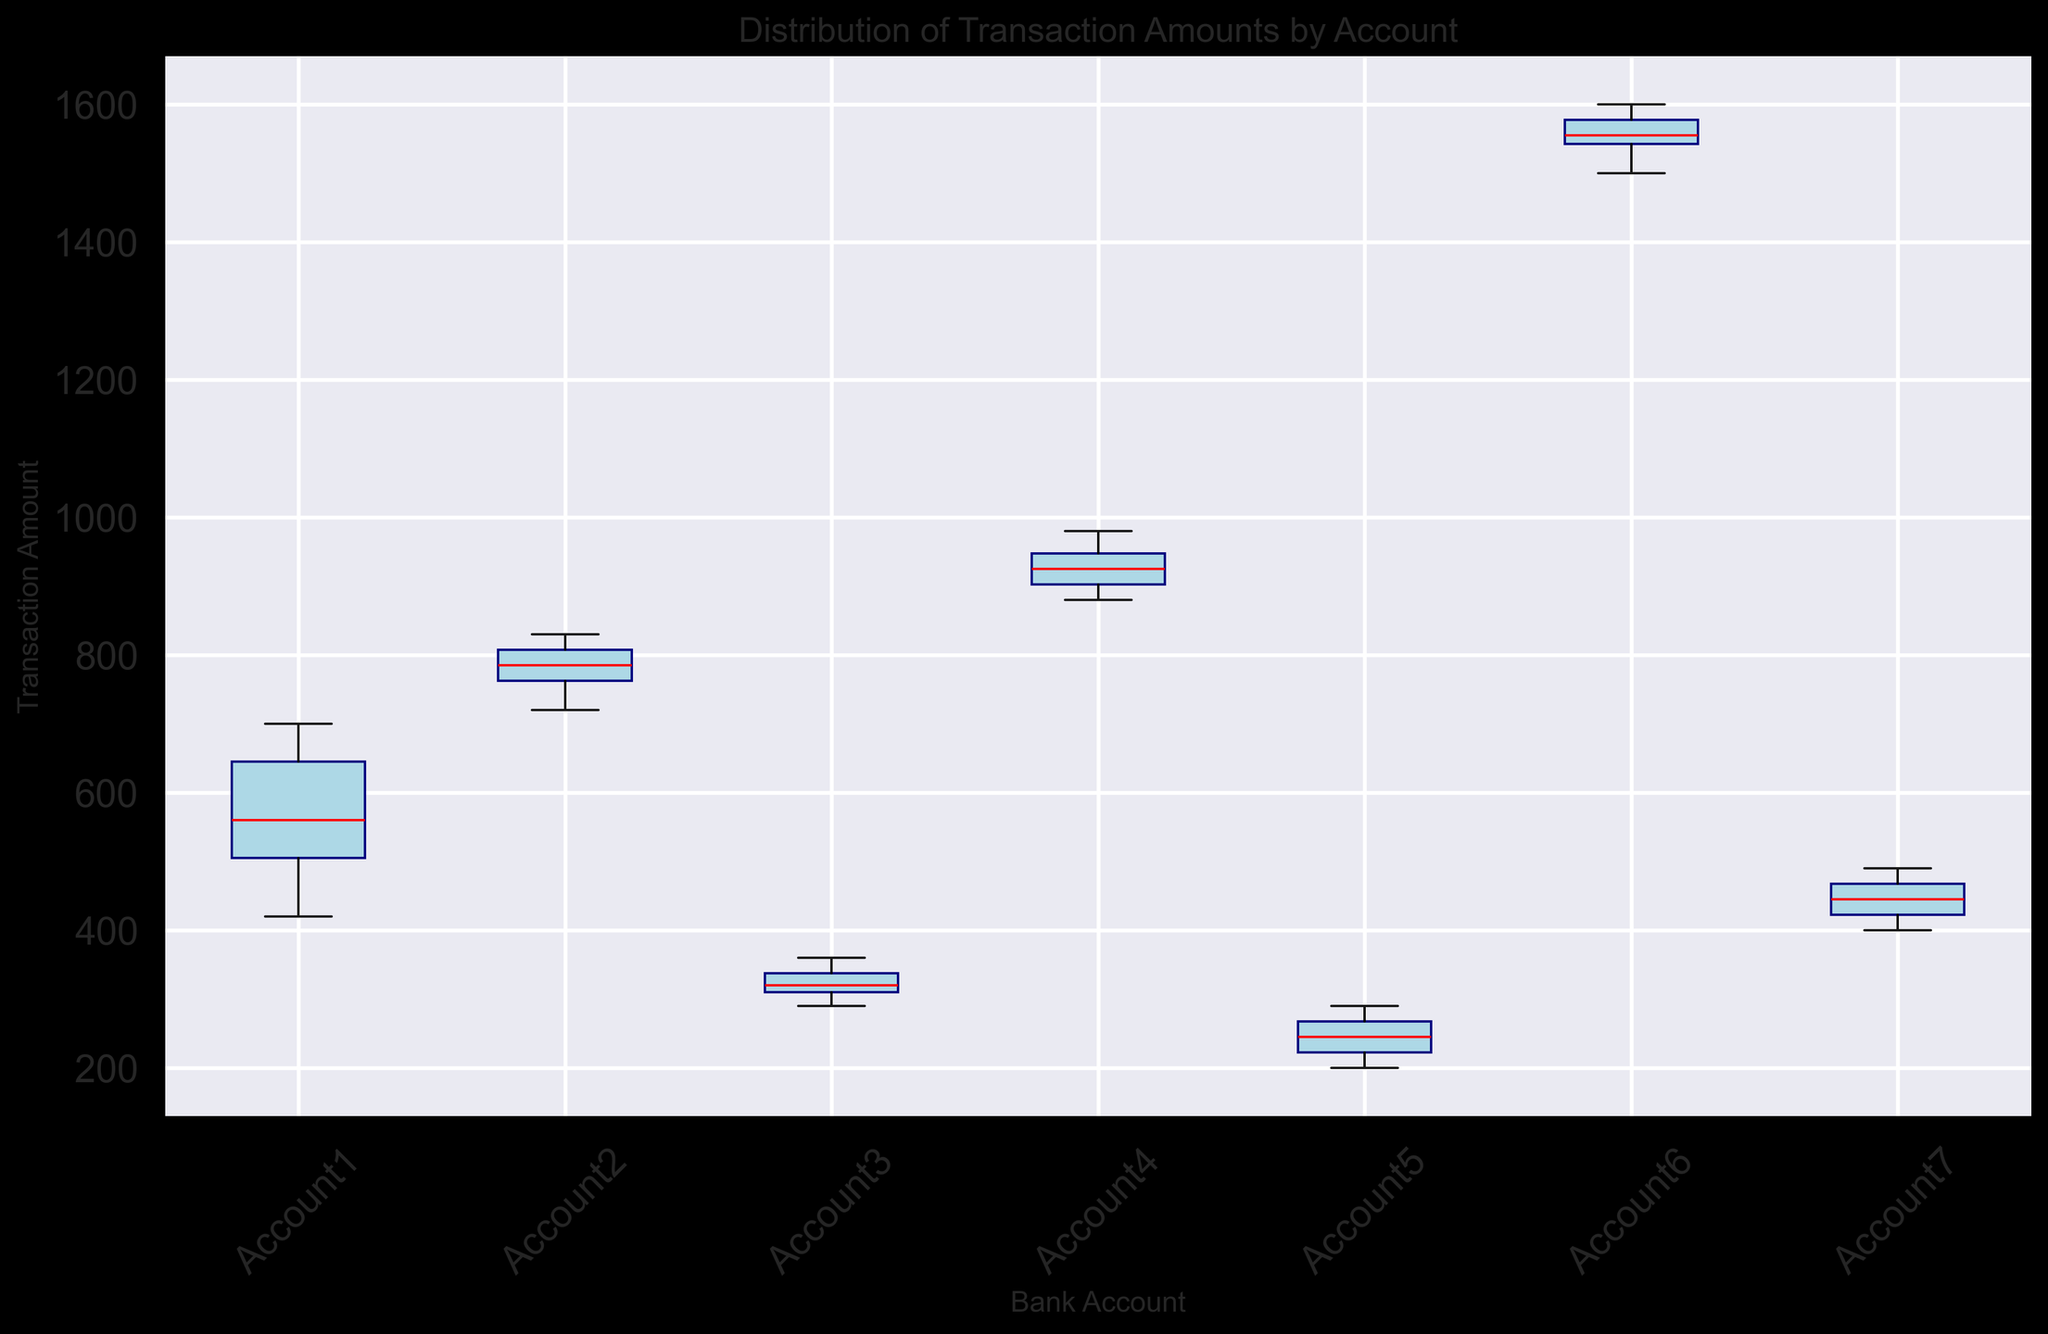Which account has the highest median transaction amount? The box plots show the central tendency and spread of transaction amounts. The median transaction amount is represented by the red line within each box. Observing the heights of these red lines, Account 6 has the highest median which is notably higher than all other accounts.
Answer: Account 6 Which account has the widest range of transaction amounts? The range of transaction amounts is indicated by the length between the whiskers of each box plot. The whiskers represent the minimum and maximum transaction amounts. Comparing the lengths, Account 6 has the longest whiskers, indicating it covers the widest range of transaction amounts.
Answer: Account 6 What is the median transaction amount for Account 3? The median transaction amount is represented by the red line in the box plot for Account 3. Based on the placement of this line within Account 3's box plot, the median transaction amount is at approximately 320.
Answer: 320 Which account has the smallest interquartile range (IQR) of transaction amounts? The interquartile range (IQR) is indicated by the height of the box (from the lower quartile to the upper quartile). By comparing the height of each box, Account 3 has the smallest IQR, indicating it has the smallest spread among the central 50% of its data.
Answer: Account 3 Comparing Account 1 and Account 7, which has a higher median transaction amount? The median transaction amount is marked by the red line in the box plot for both accounts. By observing these red lines, it is clear that Account 1's median is slightly higher than Account 7's.
Answer: Account 1 How do the transaction amounts of Account 2 and Account 4 compare in terms of their interquartile range (IQR)? The interquartile range (IQR) is the range between the first and third quartile (bottom and top of the box). Comparing the height of the boxes for Account 2 and Account 4, Account 4's IQR is wider, indicating a larger spread of the central 50% of its transaction amounts.
Answer: Account 4 has a wider IQR Which account shows the lowest minimum transaction amount? The minimum transaction amount is signified by the lower whisker of the box plot for each account. Observing the lower whiskers, Account 7 has the lowest minimum transaction amount.
Answer: Account 7 Are the transaction amounts more dispersed in Account 5 or Account 7? The dispersion or spread of transaction amounts can be assessed by looking at the lengths of the whiskers and the height of the boxes. Comparing these, Account 7's total length from the bottom whisker to the top whisker is larger, indicating more dispersed transaction amounts than those of Account 5.
Answer: Account 7 What is the approximate range of transaction amounts for Account 4? The range of transaction amounts can be identified by the distance between the top and bottom whiskers. For Account 4, the minimum value (bottom whisker) is approximately 880, and the maximum value (top whisker) is approximately 980. Thus, the range is about 100.
Answer: 100 Which account appears to have the most consistent transaction amounts? Consistency is indicated by a smaller spread or range, which can be visually identified by a smaller height of the box and shorter whiskers. Account 3 has the smallest box and short whiskers, indicating its transaction amounts are the most consistent.
Answer: Account 3 